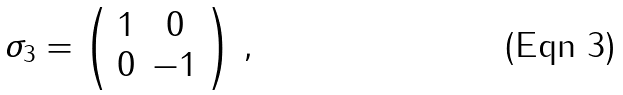Convert formula to latex. <formula><loc_0><loc_0><loc_500><loc_500>\sigma _ { 3 } = \left ( \begin{array} { c c } 1 & 0 \\ 0 & - 1 \end{array} \right ) \, ,</formula> 